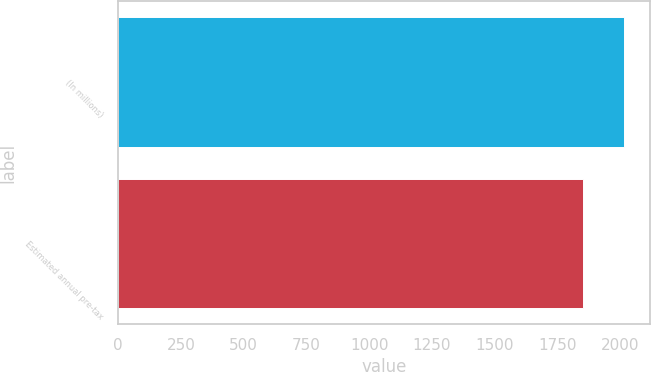<chart> <loc_0><loc_0><loc_500><loc_500><bar_chart><fcel>(In millions)<fcel>Estimated annual pre-tax<nl><fcel>2018<fcel>1851<nl></chart> 